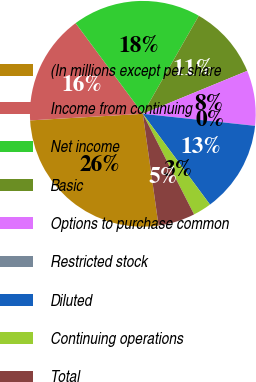Convert chart to OTSL. <chart><loc_0><loc_0><loc_500><loc_500><pie_chart><fcel>(In millions except per share<fcel>Income from continuing<fcel>Net income<fcel>Basic<fcel>Options to purchase common<fcel>Restricted stock<fcel>Diluted<fcel>Continuing operations<fcel>Total<nl><fcel>26.3%<fcel>15.78%<fcel>18.41%<fcel>10.53%<fcel>7.9%<fcel>0.01%<fcel>13.16%<fcel>2.64%<fcel>5.27%<nl></chart> 